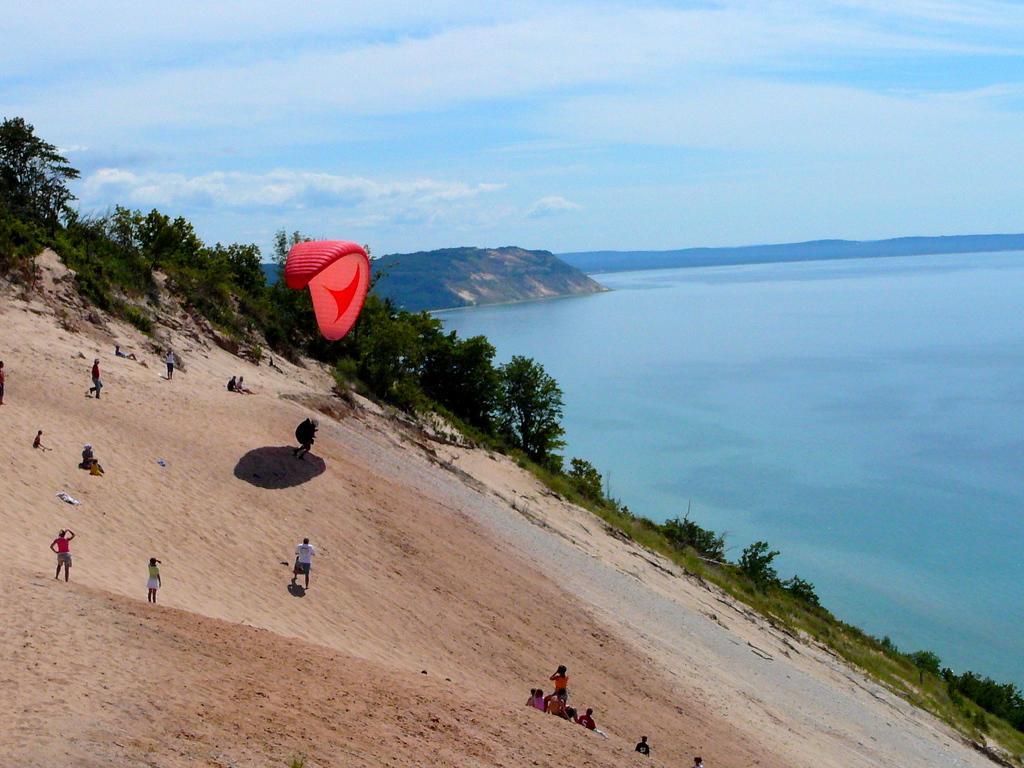Please provide a concise description of this image. On the left side of the image we can see a person paragliding and some of them are sitting. We can see people standing. In the background there is a sea, hill, trees and sky. 